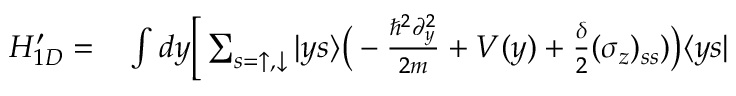Convert formula to latex. <formula><loc_0><loc_0><loc_500><loc_500>\begin{array} { r l } { H _ { 1 D } ^ { \prime } = } & \int d y \Big [ \sum _ { s = \uparrow , \downarrow } | y s \rangle \Big ( - \frac { \hbar { ^ } { 2 } \partial _ { y } ^ { 2 } } { 2 m } + V ( y ) + \frac { \delta } { 2 } ( \sigma _ { z } ) _ { s s } ) \Big ) \langle y s | } \end{array}</formula> 